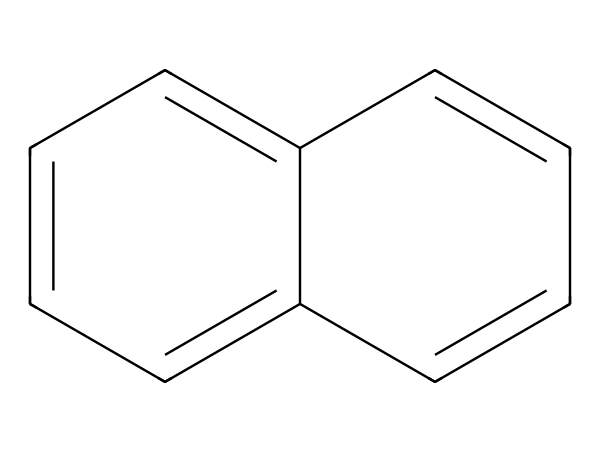What is the molecular formula of naphthalene? Counting the carbon (C) and hydrogen (H) atoms in the structure reveals that there are 10 carbon atoms and 8 hydrogen atoms, leading to the molecular formula C10H8.
Answer: C10H8 How many aromatic rings are present in naphthalene? By analyzing the structure, it can be observed that naphthalene consists of two fused benzene rings, which means it has two aromatic rings.
Answer: 2 What is the hybridization of the carbon atoms in naphthalene? The carbon atoms in naphthalene are involved in forming double bonds in a planar structure, leading to sp2 hybridization for each carbon atom.
Answer: sp2 What type of chemical bonding exists between the carbon atoms in naphthalene? The carbon atoms are connected by alternating single and double bonds, characteristic of aromatic compounds, due to the resonance within the structure.
Answer: Resonance Why is naphthalene used in mothballs? Naphthalene has insect-repelling properties, which make it effective in preventing moths and other pests from damaging vintage items, including sheet music.
Answer: Insect-repelling How does the structure of naphthalene contribute to its stability? The delocalized π electrons distributed over the aromatic system provide extra stability through resonance, making naphthalene a stable aromatic compound.
Answer: Resonance What is the implication of naphthalene's planar structure on its interactions? The planarity of naphthalene facilitates π-π stacking interactions between layers of molecules, enhancing its effectiveness in solid-phase applications like mothballs.
Answer: π-π stacking 